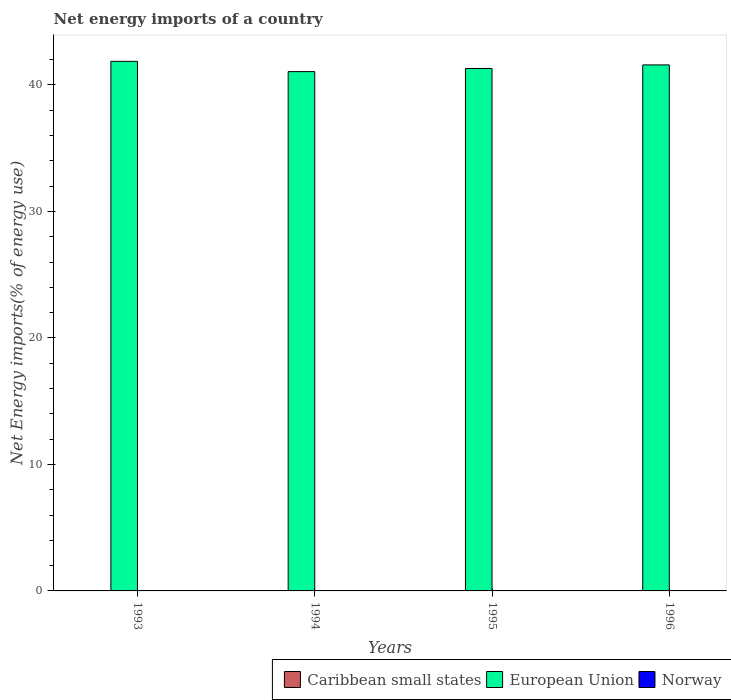Are the number of bars on each tick of the X-axis equal?
Give a very brief answer. Yes. How many bars are there on the 2nd tick from the left?
Make the answer very short. 1. How many bars are there on the 2nd tick from the right?
Provide a succinct answer. 1. What is the net energy imports in Norway in 1996?
Offer a very short reply. 0. Across all years, what is the maximum net energy imports in European Union?
Provide a short and direct response. 41.86. Across all years, what is the minimum net energy imports in European Union?
Offer a very short reply. 41.05. What is the total net energy imports in European Union in the graph?
Your answer should be compact. 165.79. What is the difference between the net energy imports in European Union in 1995 and that in 1996?
Your answer should be compact. -0.28. What is the difference between the net energy imports in Caribbean small states in 1996 and the net energy imports in European Union in 1995?
Keep it short and to the point. -41.3. What is the average net energy imports in European Union per year?
Provide a short and direct response. 41.45. What is the ratio of the net energy imports in European Union in 1993 to that in 1996?
Your answer should be very brief. 1.01. What is the difference between the highest and the second highest net energy imports in European Union?
Ensure brevity in your answer.  0.28. What is the difference between the highest and the lowest net energy imports in European Union?
Ensure brevity in your answer.  0.81. How many years are there in the graph?
Provide a short and direct response. 4. What is the difference between two consecutive major ticks on the Y-axis?
Give a very brief answer. 10. Are the values on the major ticks of Y-axis written in scientific E-notation?
Your answer should be compact. No. Where does the legend appear in the graph?
Provide a short and direct response. Bottom right. How many legend labels are there?
Offer a terse response. 3. How are the legend labels stacked?
Your response must be concise. Horizontal. What is the title of the graph?
Keep it short and to the point. Net energy imports of a country. Does "Slovak Republic" appear as one of the legend labels in the graph?
Make the answer very short. No. What is the label or title of the Y-axis?
Your answer should be compact. Net Energy imports(% of energy use). What is the Net Energy imports(% of energy use) in European Union in 1993?
Provide a succinct answer. 41.86. What is the Net Energy imports(% of energy use) in Caribbean small states in 1994?
Offer a very short reply. 0. What is the Net Energy imports(% of energy use) of European Union in 1994?
Give a very brief answer. 41.05. What is the Net Energy imports(% of energy use) of Caribbean small states in 1995?
Your answer should be very brief. 0. What is the Net Energy imports(% of energy use) of European Union in 1995?
Offer a terse response. 41.3. What is the Net Energy imports(% of energy use) of Caribbean small states in 1996?
Give a very brief answer. 0. What is the Net Energy imports(% of energy use) in European Union in 1996?
Offer a very short reply. 41.58. What is the Net Energy imports(% of energy use) in Norway in 1996?
Make the answer very short. 0. Across all years, what is the maximum Net Energy imports(% of energy use) of European Union?
Your response must be concise. 41.86. Across all years, what is the minimum Net Energy imports(% of energy use) of European Union?
Your response must be concise. 41.05. What is the total Net Energy imports(% of energy use) of European Union in the graph?
Offer a terse response. 165.79. What is the difference between the Net Energy imports(% of energy use) of European Union in 1993 and that in 1994?
Offer a very short reply. 0.81. What is the difference between the Net Energy imports(% of energy use) of European Union in 1993 and that in 1995?
Provide a succinct answer. 0.56. What is the difference between the Net Energy imports(% of energy use) of European Union in 1993 and that in 1996?
Your answer should be very brief. 0.28. What is the difference between the Net Energy imports(% of energy use) of European Union in 1994 and that in 1995?
Offer a terse response. -0.25. What is the difference between the Net Energy imports(% of energy use) in European Union in 1994 and that in 1996?
Ensure brevity in your answer.  -0.53. What is the difference between the Net Energy imports(% of energy use) of European Union in 1995 and that in 1996?
Ensure brevity in your answer.  -0.28. What is the average Net Energy imports(% of energy use) of Caribbean small states per year?
Offer a very short reply. 0. What is the average Net Energy imports(% of energy use) in European Union per year?
Give a very brief answer. 41.45. What is the average Net Energy imports(% of energy use) of Norway per year?
Your response must be concise. 0. What is the ratio of the Net Energy imports(% of energy use) of European Union in 1993 to that in 1994?
Offer a very short reply. 1.02. What is the ratio of the Net Energy imports(% of energy use) of European Union in 1993 to that in 1995?
Keep it short and to the point. 1.01. What is the ratio of the Net Energy imports(% of energy use) in European Union in 1993 to that in 1996?
Your response must be concise. 1.01. What is the ratio of the Net Energy imports(% of energy use) of European Union in 1994 to that in 1996?
Ensure brevity in your answer.  0.99. What is the ratio of the Net Energy imports(% of energy use) of European Union in 1995 to that in 1996?
Your answer should be compact. 0.99. What is the difference between the highest and the second highest Net Energy imports(% of energy use) of European Union?
Provide a short and direct response. 0.28. What is the difference between the highest and the lowest Net Energy imports(% of energy use) of European Union?
Offer a terse response. 0.81. 